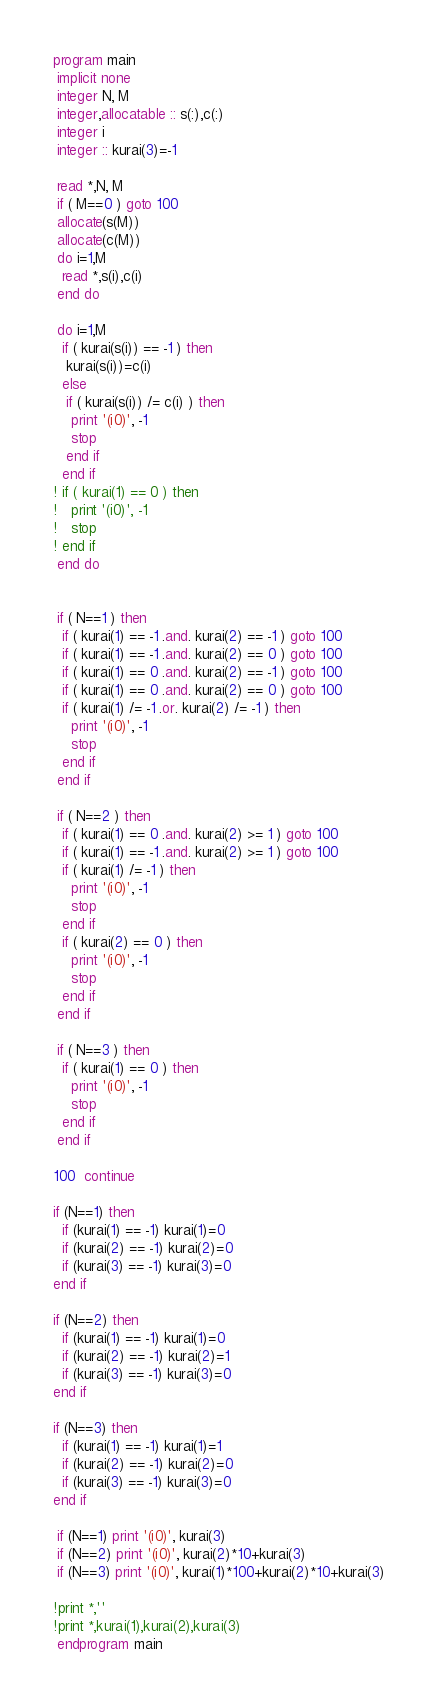<code> <loc_0><loc_0><loc_500><loc_500><_FORTRAN_>program main
 implicit none
 integer N, M
 integer,allocatable :: s(:),c(:)
 integer i
 integer :: kurai(3)=-1

 read *,N, M
 if ( M==0 ) goto 100
 allocate(s(M))
 allocate(c(M))
 do i=1,M
  read *,s(i),c(i)
 end do

 do i=1,M
  if ( kurai(s(i)) == -1 ) then
   kurai(s(i))=c(i)
  else
   if ( kurai(s(i)) /= c(i) ) then
    print '(i0)', -1
    stop
   end if
  end if
! if ( kurai(1) == 0 ) then
!   print '(i0)', -1
!   stop
! end if
 end do


 if ( N==1 ) then
  if ( kurai(1) == -1 .and. kurai(2) == -1 ) goto 100
  if ( kurai(1) == -1 .and. kurai(2) == 0 ) goto 100
  if ( kurai(1) == 0 .and. kurai(2) == -1 ) goto 100
  if ( kurai(1) == 0 .and. kurai(2) == 0 ) goto 100
  if ( kurai(1) /= -1 .or. kurai(2) /= -1 ) then
    print '(i0)', -1
    stop
  end if
 end if 

 if ( N==2 ) then
  if ( kurai(1) == 0 .and. kurai(2) >= 1 ) goto 100
  if ( kurai(1) == -1 .and. kurai(2) >= 1 ) goto 100
  if ( kurai(1) /= -1 ) then
    print '(i0)', -1
    stop
  end if
  if ( kurai(2) == 0 ) then
    print '(i0)', -1
    stop
  end if
 end if

 if ( N==3 ) then
  if ( kurai(1) == 0 ) then
    print '(i0)', -1
    stop
  end if
 end if

100  continue

if (N==1) then
  if (kurai(1) == -1) kurai(1)=0
  if (kurai(2) == -1) kurai(2)=0
  if (kurai(3) == -1) kurai(3)=0
end if

if (N==2) then
  if (kurai(1) == -1) kurai(1)=0
  if (kurai(2) == -1) kurai(2)=1
  if (kurai(3) == -1) kurai(3)=0
end if

if (N==3) then
  if (kurai(1) == -1) kurai(1)=1
  if (kurai(2) == -1) kurai(2)=0
  if (kurai(3) == -1) kurai(3)=0
end if

 if (N==1) print '(i0)', kurai(3)
 if (N==2) print '(i0)', kurai(2)*10+kurai(3)
 if (N==3) print '(i0)', kurai(1)*100+kurai(2)*10+kurai(3)

!print *,''
!print *,kurai(1),kurai(2),kurai(3)
 endprogram main







</code> 